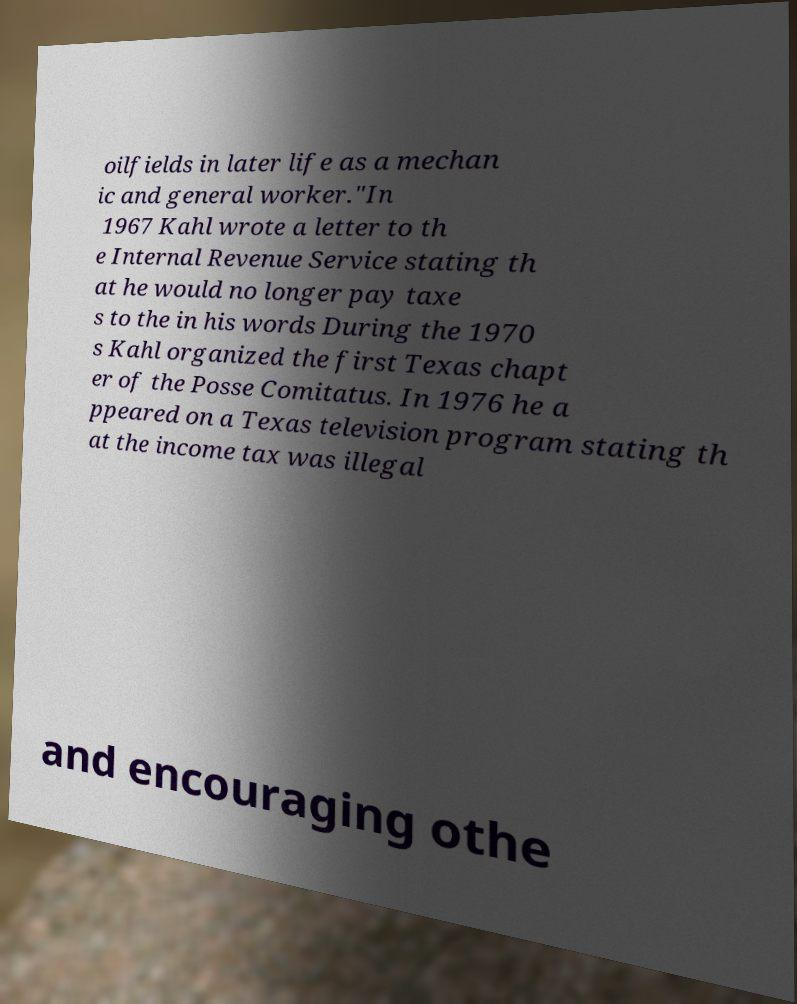What messages or text are displayed in this image? I need them in a readable, typed format. oilfields in later life as a mechan ic and general worker."In 1967 Kahl wrote a letter to th e Internal Revenue Service stating th at he would no longer pay taxe s to the in his words During the 1970 s Kahl organized the first Texas chapt er of the Posse Comitatus. In 1976 he a ppeared on a Texas television program stating th at the income tax was illegal and encouraging othe 